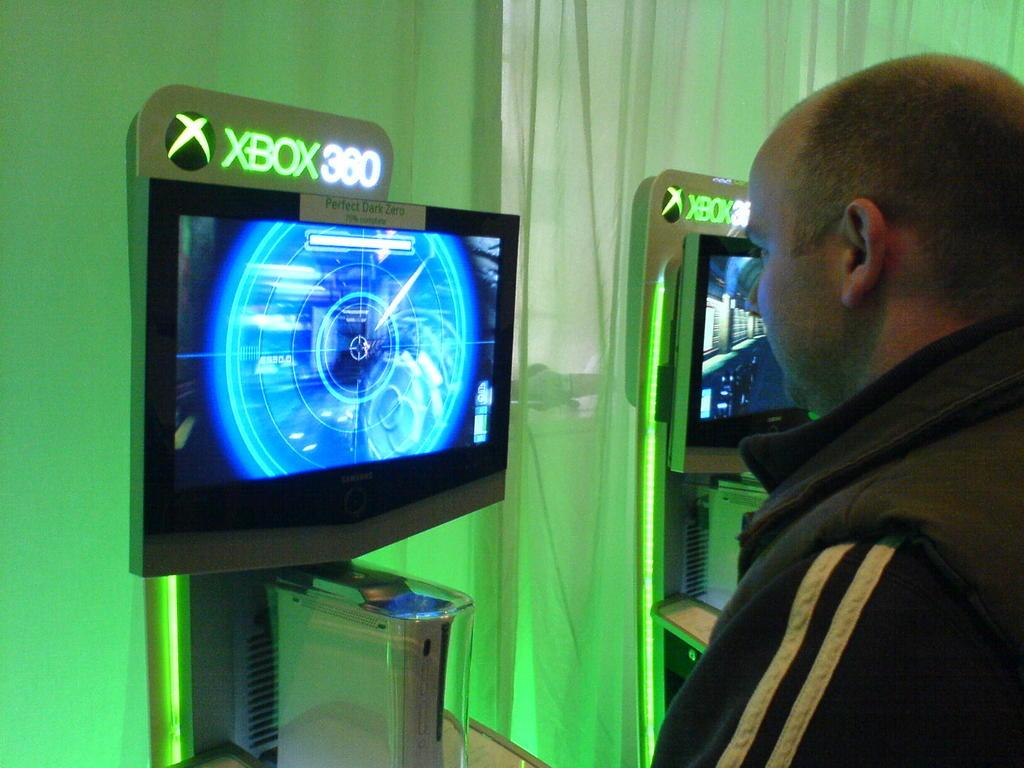<image>
Offer a succinct explanation of the picture presented. A man watching a screen with XBOX360 written on the top. 